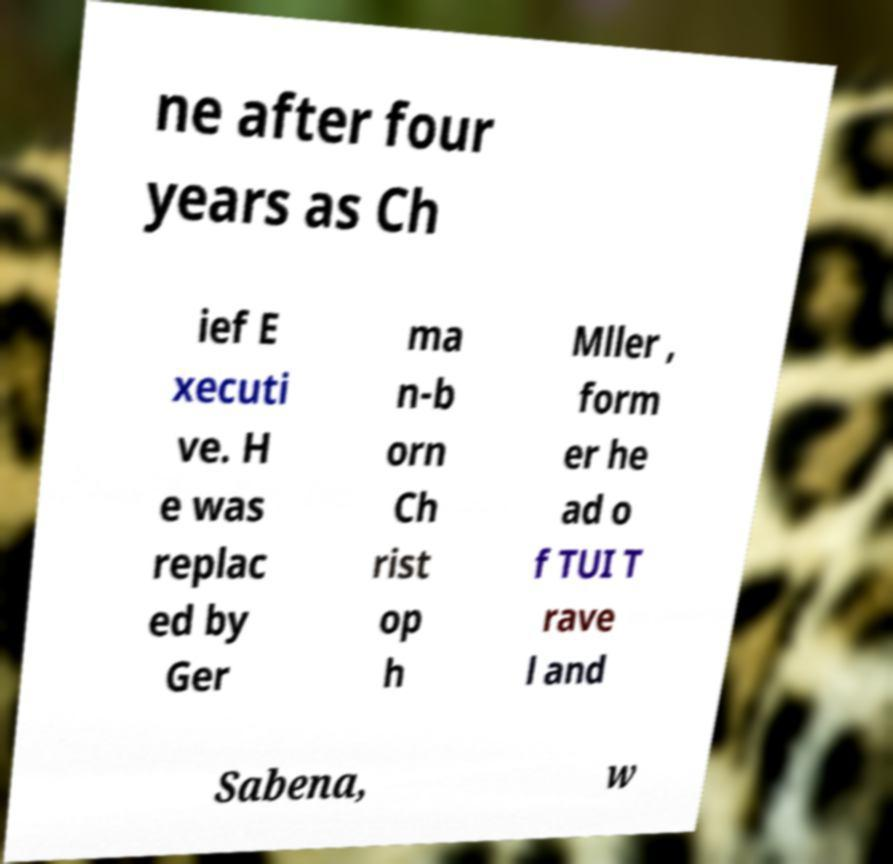Could you assist in decoding the text presented in this image and type it out clearly? ne after four years as Ch ief E xecuti ve. H e was replac ed by Ger ma n-b orn Ch rist op h Mller , form er he ad o f TUI T rave l and Sabena, w 